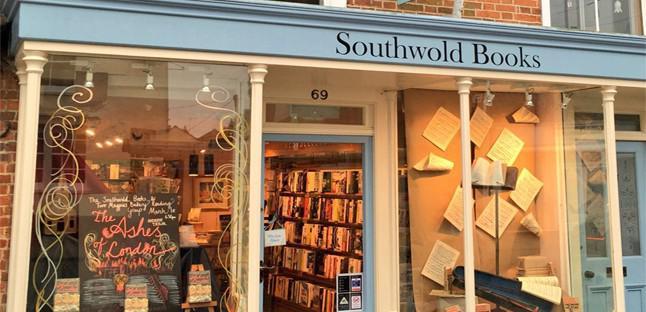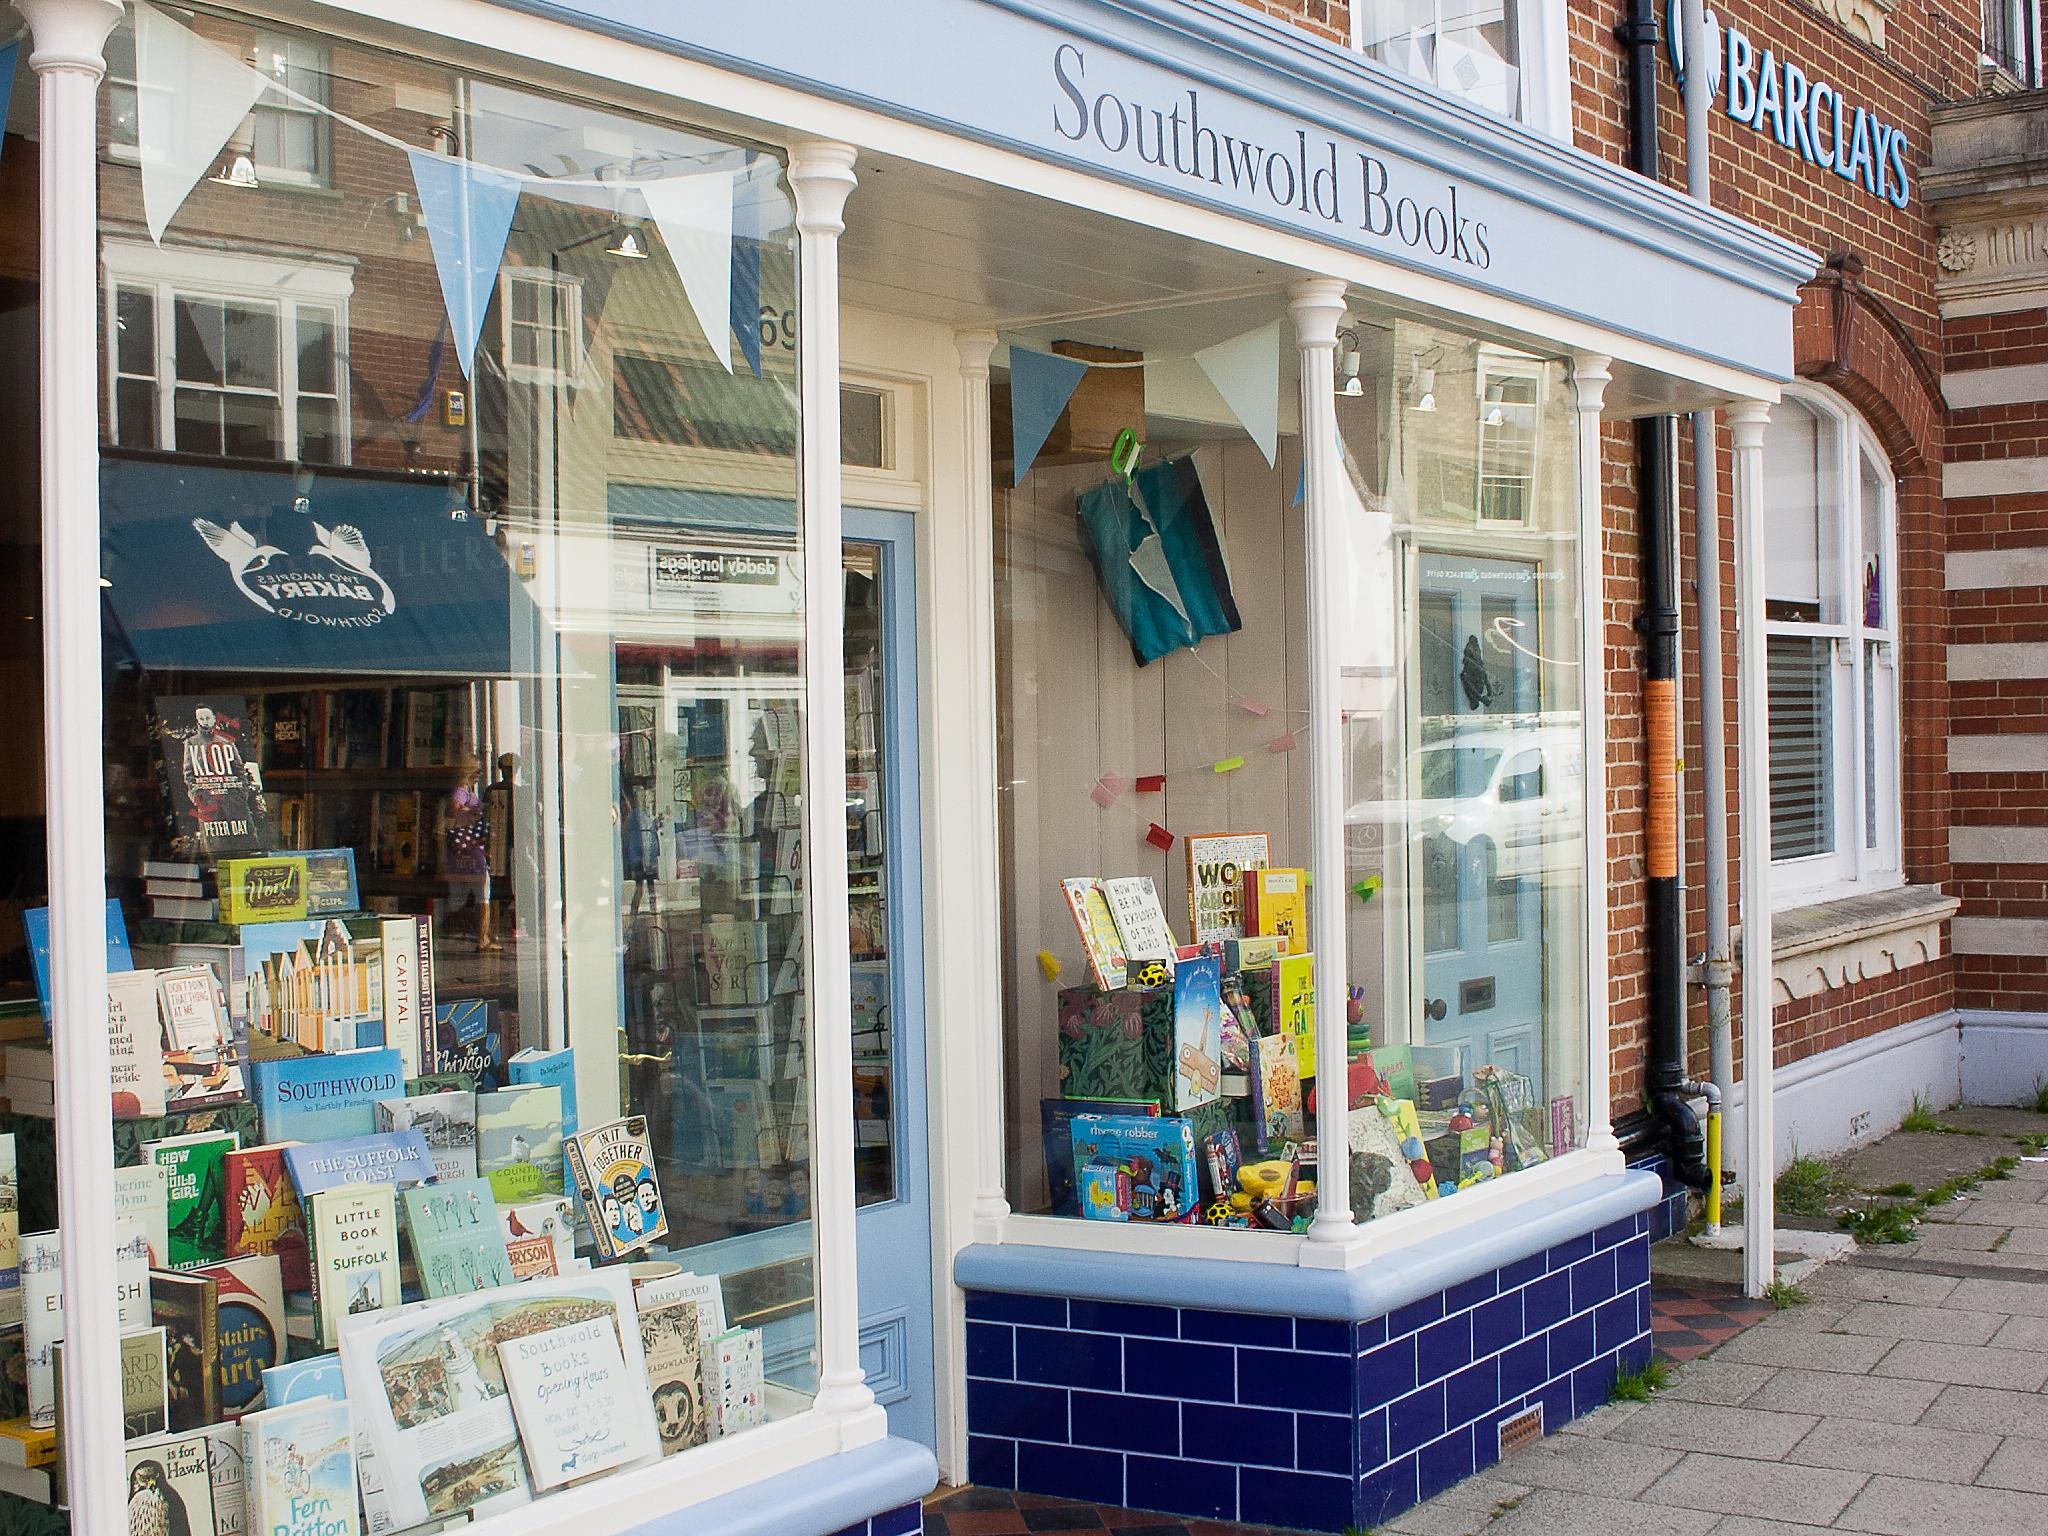The first image is the image on the left, the second image is the image on the right. Evaluate the accuracy of this statement regarding the images: "The bookstore on the right has a banner of pennants in different shades of blue.". Is it true? Answer yes or no. Yes. The first image is the image on the left, the second image is the image on the right. For the images shown, is this caption "There is an open door between two display windows of a shelf of books and at the bottom there a blue bricks." true? Answer yes or no. No. 